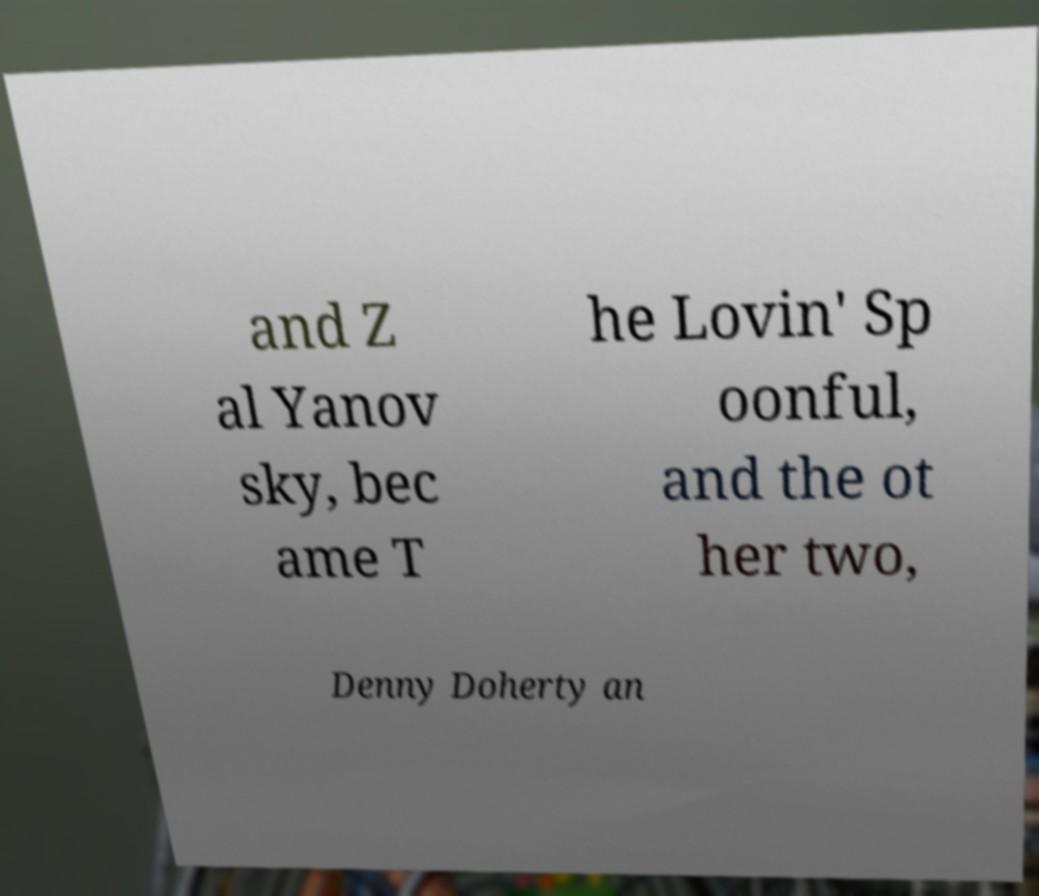Please identify and transcribe the text found in this image. and Z al Yanov sky, bec ame T he Lovin' Sp oonful, and the ot her two, Denny Doherty an 